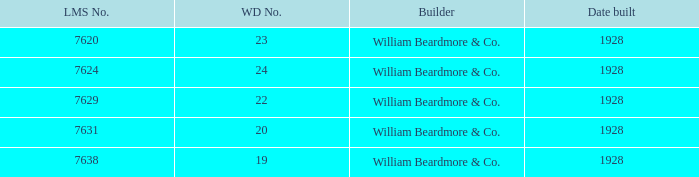Determine the maker for wd numeral equating to 22 William Beardmore & Co. 